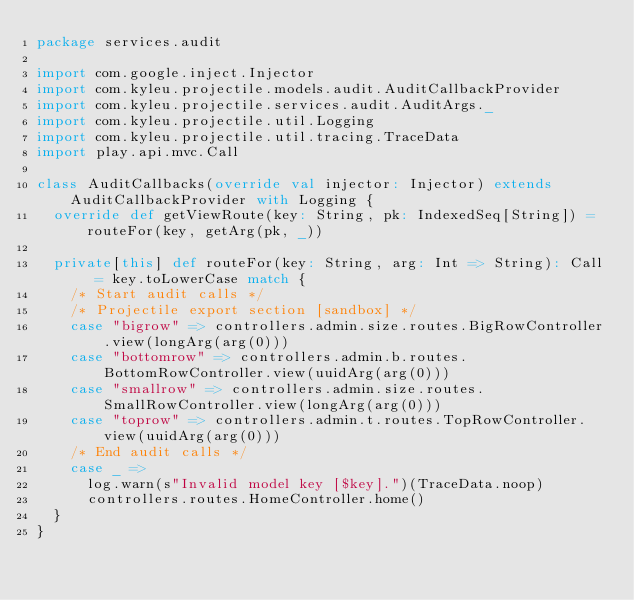<code> <loc_0><loc_0><loc_500><loc_500><_Scala_>package services.audit

import com.google.inject.Injector
import com.kyleu.projectile.models.audit.AuditCallbackProvider
import com.kyleu.projectile.services.audit.AuditArgs._
import com.kyleu.projectile.util.Logging
import com.kyleu.projectile.util.tracing.TraceData
import play.api.mvc.Call

class AuditCallbacks(override val injector: Injector) extends AuditCallbackProvider with Logging {
  override def getViewRoute(key: String, pk: IndexedSeq[String]) = routeFor(key, getArg(pk, _))

  private[this] def routeFor(key: String, arg: Int => String): Call = key.toLowerCase match {
    /* Start audit calls */
    /* Projectile export section [sandbox] */
    case "bigrow" => controllers.admin.size.routes.BigRowController.view(longArg(arg(0)))
    case "bottomrow" => controllers.admin.b.routes.BottomRowController.view(uuidArg(arg(0)))
    case "smallrow" => controllers.admin.size.routes.SmallRowController.view(longArg(arg(0)))
    case "toprow" => controllers.admin.t.routes.TopRowController.view(uuidArg(arg(0)))
    /* End audit calls */
    case _ =>
      log.warn(s"Invalid model key [$key].")(TraceData.noop)
      controllers.routes.HomeController.home()
  }
}
</code> 